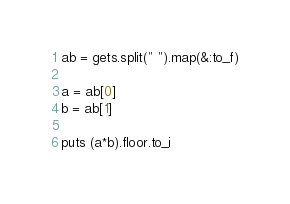<code> <loc_0><loc_0><loc_500><loc_500><_Ruby_>ab = gets.split(" ").map(&:to_f)

a = ab[0]
b = ab[1]

puts (a*b).floor.to_i</code> 